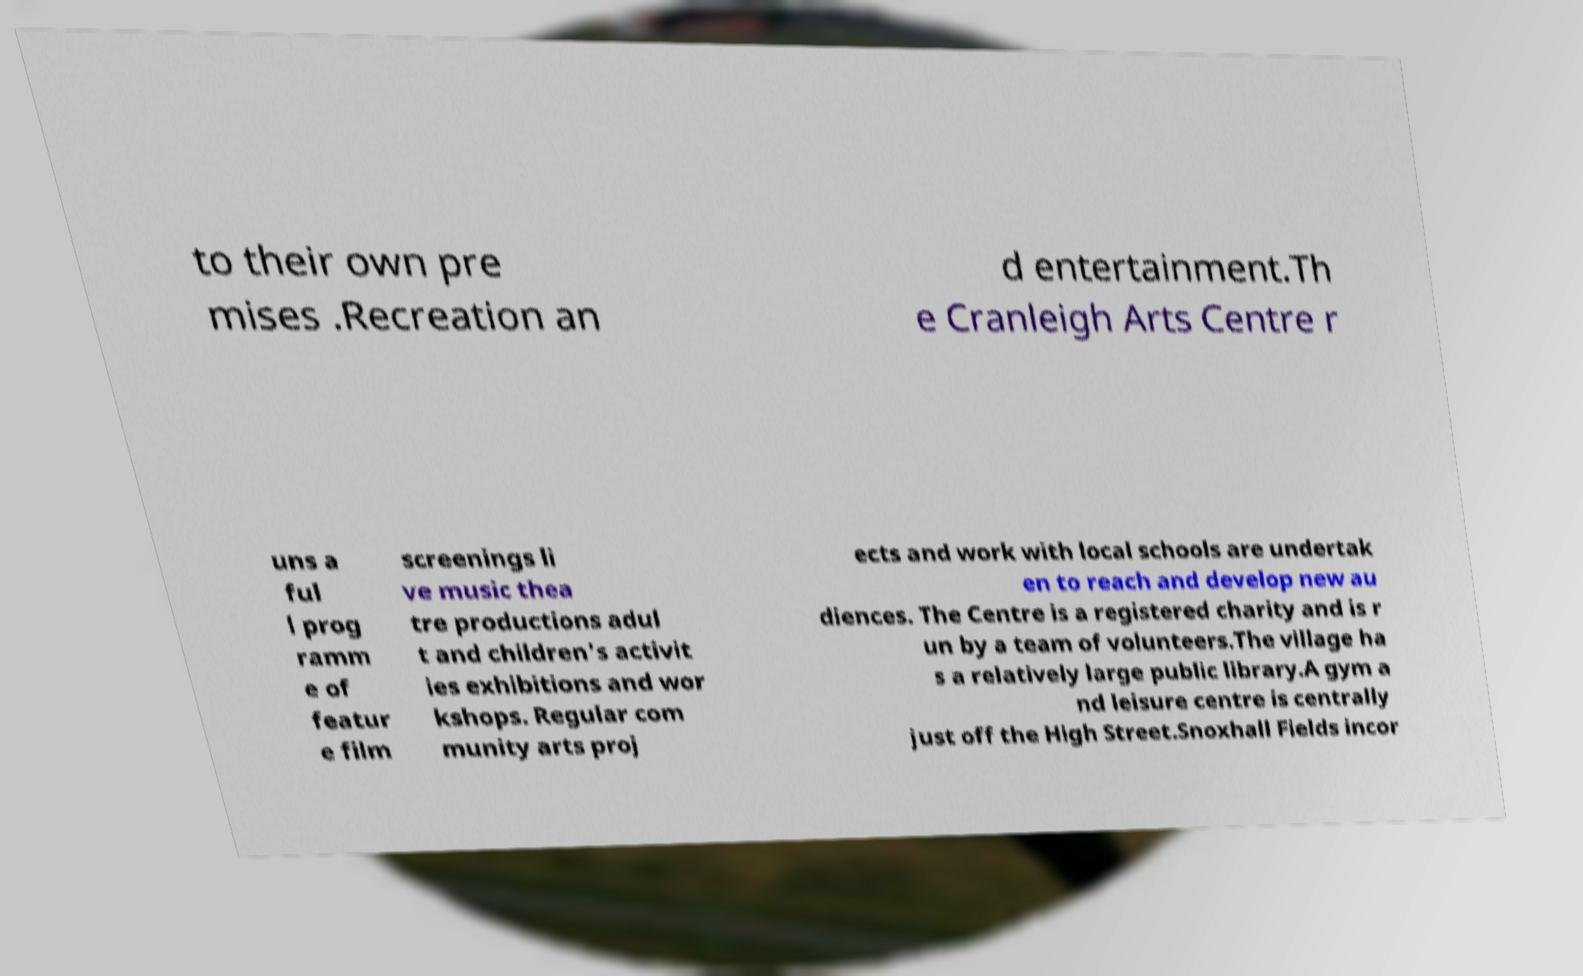Can you read and provide the text displayed in the image?This photo seems to have some interesting text. Can you extract and type it out for me? to their own pre mises .Recreation an d entertainment.Th e Cranleigh Arts Centre r uns a ful l prog ramm e of featur e film screenings li ve music thea tre productions adul t and children's activit ies exhibitions and wor kshops. Regular com munity arts proj ects and work with local schools are undertak en to reach and develop new au diences. The Centre is a registered charity and is r un by a team of volunteers.The village ha s a relatively large public library.A gym a nd leisure centre is centrally just off the High Street.Snoxhall Fields incor 